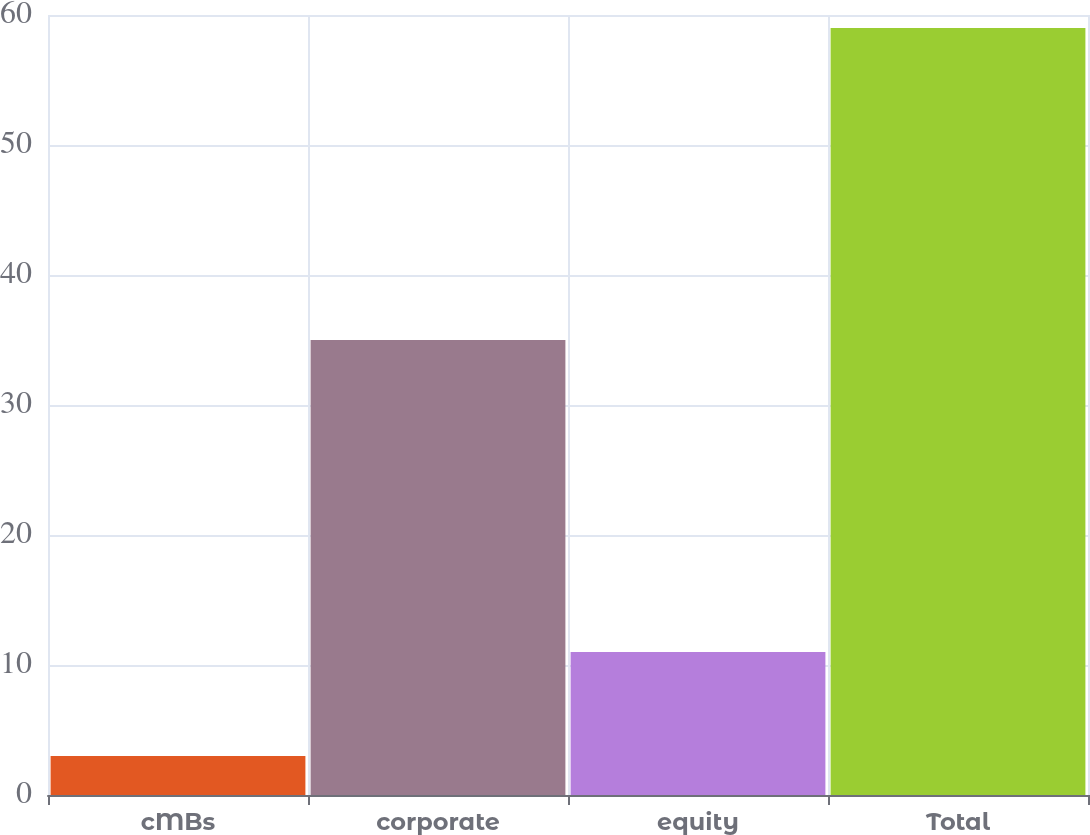<chart> <loc_0><loc_0><loc_500><loc_500><bar_chart><fcel>cMBs<fcel>corporate<fcel>equity<fcel>Total<nl><fcel>3<fcel>35<fcel>11<fcel>59<nl></chart> 